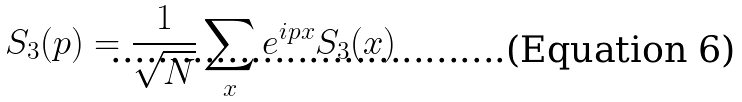<formula> <loc_0><loc_0><loc_500><loc_500>S _ { 3 } ( p ) = \frac { 1 } { \sqrt { N } } \sum _ { x } e ^ { i p x } S _ { 3 } ( x )</formula> 